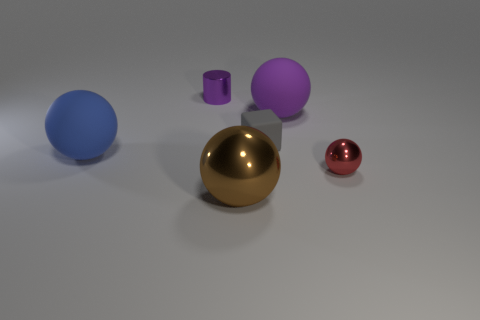What is the shape of the purple rubber thing?
Give a very brief answer. Sphere. How many other things are the same shape as the large blue thing?
Give a very brief answer. 3. What is the material of the blue thing that is left of the ball that is behind the large rubber sphere to the left of the tiny rubber object?
Provide a short and direct response. Rubber. Is there a thing of the same color as the metallic cylinder?
Provide a short and direct response. Yes. There is a matte cube that is the same size as the purple shiny object; what color is it?
Provide a short and direct response. Gray. There is a ball on the left side of the brown shiny ball; how many tiny gray cubes are behind it?
Make the answer very short. 1. How many things are things left of the large brown metallic object or matte blocks?
Your answer should be very brief. 3. How many small balls have the same material as the cylinder?
Provide a short and direct response. 1. There is a rubber object that is the same color as the cylinder; what shape is it?
Your response must be concise. Sphere. Are there an equal number of blue rubber balls that are on the right side of the brown object and big yellow spheres?
Your answer should be compact. Yes. 